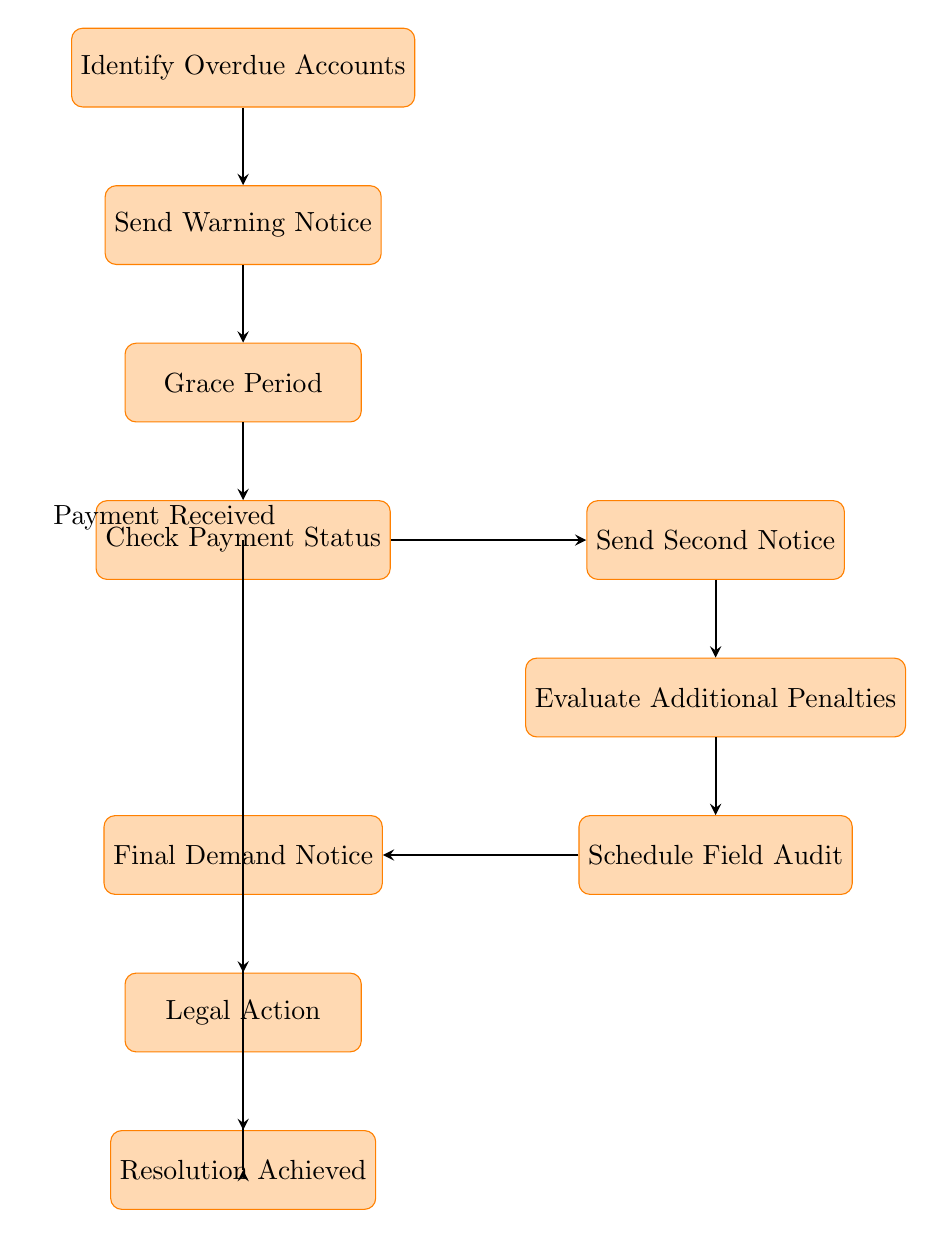What is the first step in the process? The first step, as indicated in the diagram, is "Identify Overdue Accounts."
Answer: Identify Overdue Accounts How many steps are there in the flow chart? Counting the nodes in the flow chart, there are a total of eight steps from the start to the end.
Answer: Eight What is the action taken after sending a warning notice? After sending the warning notice, the next action is to provide a "Grace Period" for the business to respond or pay.
Answer: Grace Period What happens if payment is received after checking payment status? If payment is received after the "Check Payment Status" step, the flow moves directly to "Resolution Achieved," bypassing further steps in the process.
Answer: Resolution Achieved What action follows the evaluation of additional penalties? The action that follows the evaluation of additional penalties is to "Schedule Field Audit" for the business.
Answer: Schedule Field Audit Which process involves sending an official demand for payment? The process that involves sending an official demand for payment is "Final Demand Notice."
Answer: Final Demand Notice In total, how many actions must be taken before legal action is considered? Before reaching the "Legal Action" step, a total of six actions must be completed: identifying accounts, sending warning notice, grace period, checking payment status, sending second notice, and evaluating additional penalties.
Answer: Six What is the final step in the process? The final step, as represented in the diagram, is "Resolution Achieved."
Answer: Resolution Achieved Which step includes applying late fees or interest? The step which includes applying late fees or interest is "Evaluate Additional Penalties."
Answer: Evaluate Additional Penalties 